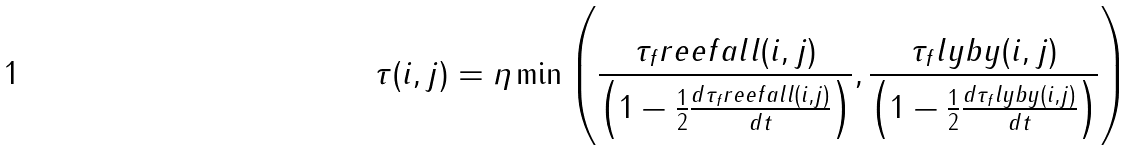<formula> <loc_0><loc_0><loc_500><loc_500>\tau ( i , j ) = \eta \min \left ( \frac { \tau _ { f } r e e f a l l ( i , j ) } { \left ( 1 - \frac { 1 } { 2 } \frac { d \tau _ { f } r e e f a l l ( i , j ) } { d t } \right ) } , \frac { \tau _ { f } l y b y ( i , j ) } { \left ( 1 - \frac { 1 } { 2 } \frac { d \tau _ { f } l y b y ( i , j ) } { d t } \right ) } \right )</formula> 